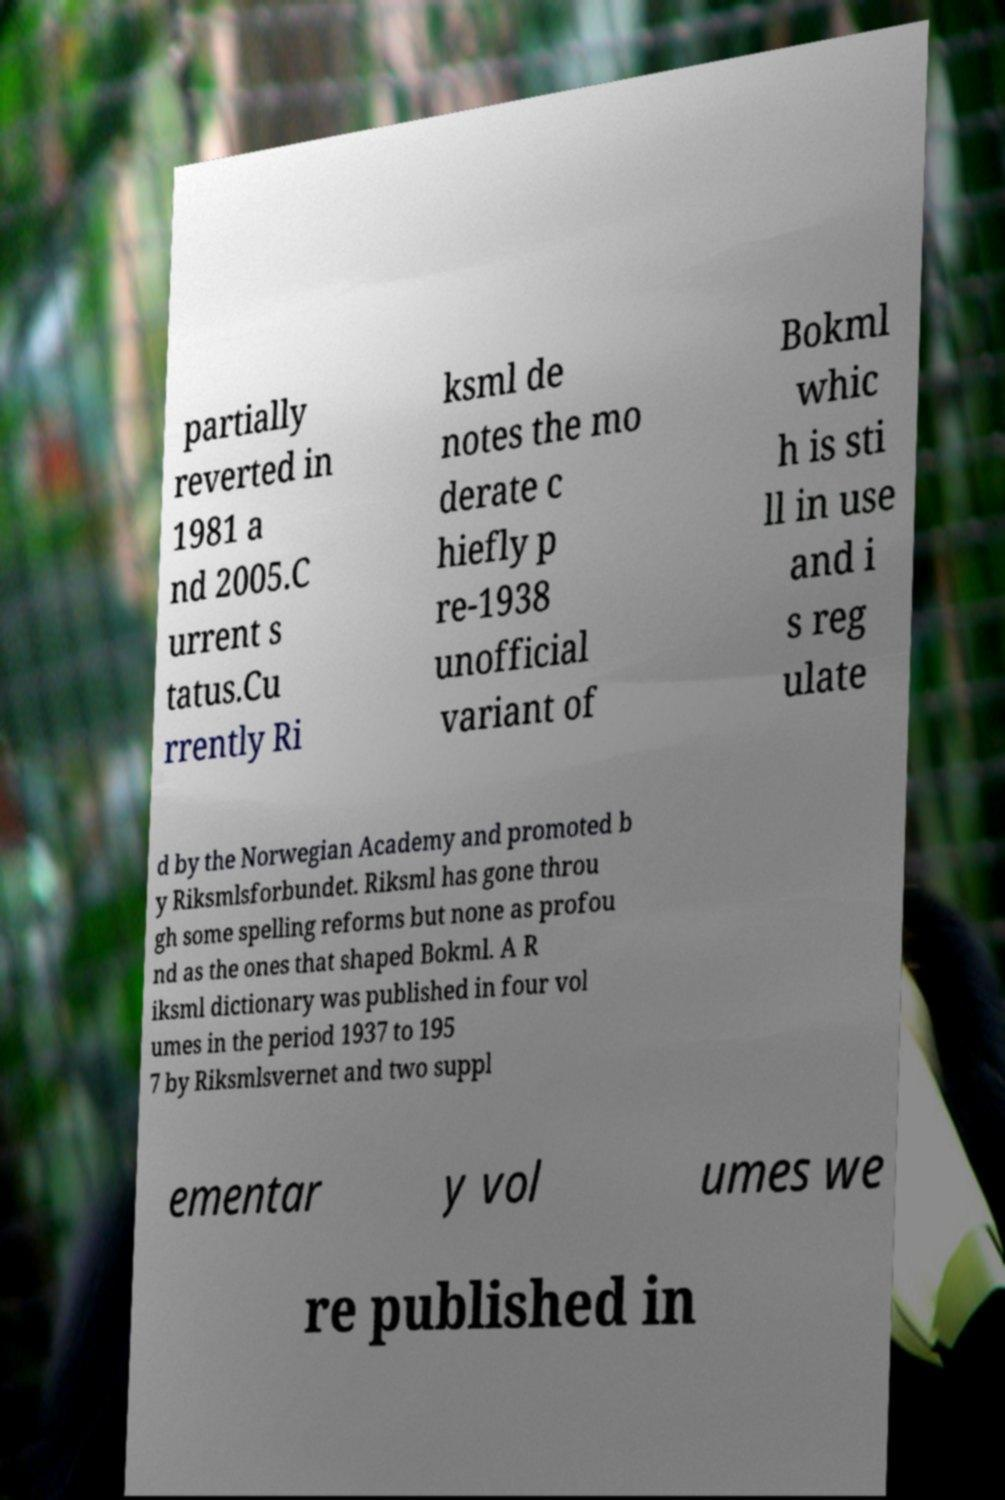For documentation purposes, I need the text within this image transcribed. Could you provide that? partially reverted in 1981 a nd 2005.C urrent s tatus.Cu rrently Ri ksml de notes the mo derate c hiefly p re-1938 unofficial variant of Bokml whic h is sti ll in use and i s reg ulate d by the Norwegian Academy and promoted b y Riksmlsforbundet. Riksml has gone throu gh some spelling reforms but none as profou nd as the ones that shaped Bokml. A R iksml dictionary was published in four vol umes in the period 1937 to 195 7 by Riksmlsvernet and two suppl ementar y vol umes we re published in 